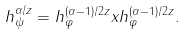Convert formula to latex. <formula><loc_0><loc_0><loc_500><loc_500>h _ { \psi } ^ { \alpha / z } = h _ { \varphi } ^ { ( \alpha - 1 ) / 2 z } x h _ { \varphi } ^ { ( \alpha - 1 ) / 2 z } .</formula> 